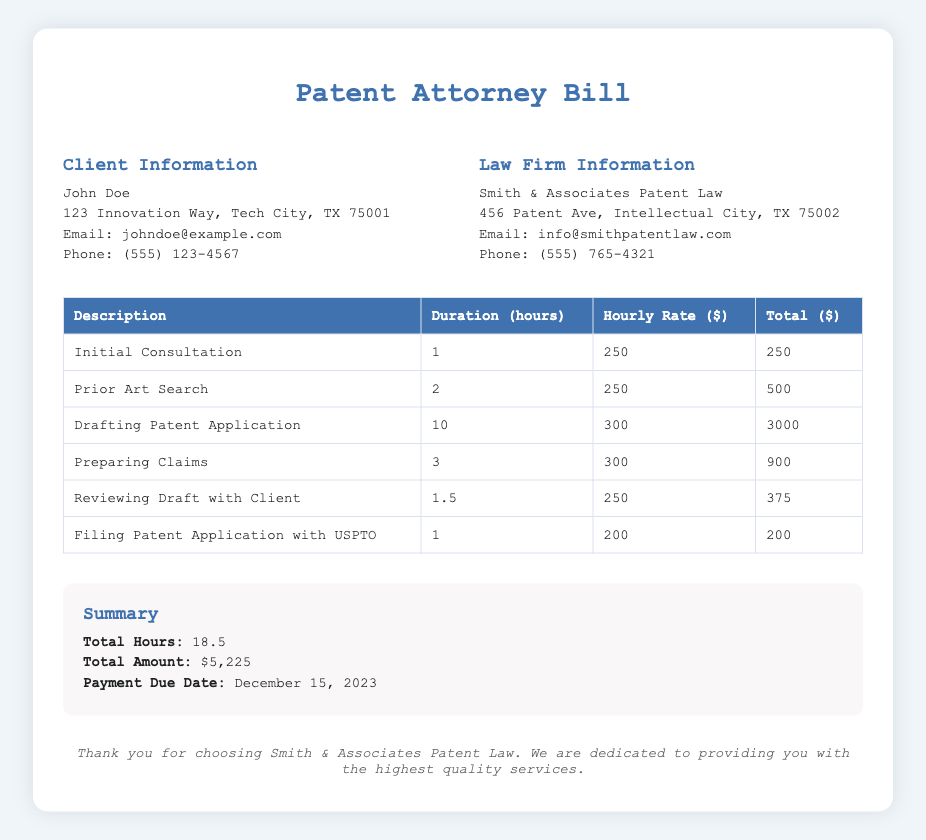What is the name of the client? The client's name is explicitly stated in the document under Client Information.
Answer: John Doe What is the total amount due? The total amount is summarized in the document under the Summary section, combining all services.
Answer: $5,225 How much is the hourly rate for drafting the patent application? The hourly rate for drafting is specified in the table for that particular service.
Answer: $300 What is the duration of the initial consultation? The duration is clearly listed in the table under the Description of services provided.
Answer: 1 hour What date is the payment due? The due date for payment is noted in the Summary section of the document.
Answer: December 15, 2023 How many hours were spent on preparing claims? The hours spent is mentioned in the item's table under the relevant service.
Answer: 3 What law firm provided the patent services? The law firm's name is indicated in the Law Firm Information section of the document.
Answer: Smith & Associates Patent Law What is the total number of hours billed? The total hours is provided in the Summary section, consolidating all service durations.
Answer: 18.5 